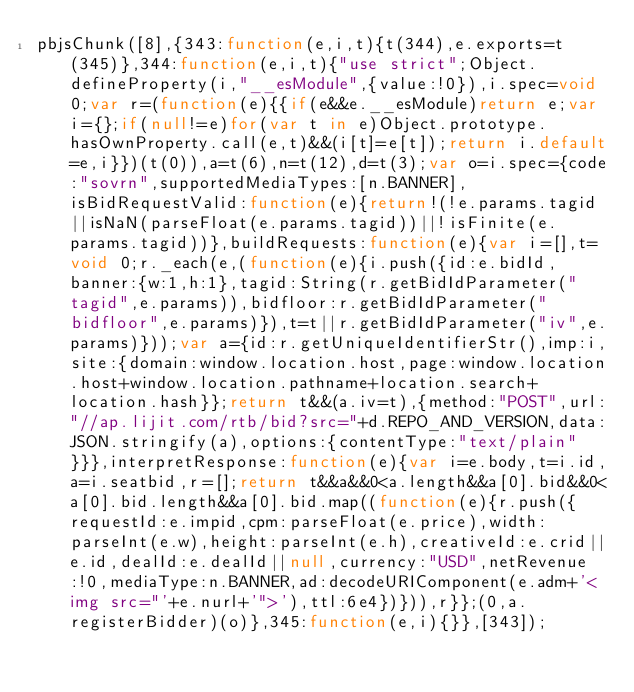<code> <loc_0><loc_0><loc_500><loc_500><_JavaScript_>pbjsChunk([8],{343:function(e,i,t){t(344),e.exports=t(345)},344:function(e,i,t){"use strict";Object.defineProperty(i,"__esModule",{value:!0}),i.spec=void 0;var r=(function(e){{if(e&&e.__esModule)return e;var i={};if(null!=e)for(var t in e)Object.prototype.hasOwnProperty.call(e,t)&&(i[t]=e[t]);return i.default=e,i}})(t(0)),a=t(6),n=t(12),d=t(3);var o=i.spec={code:"sovrn",supportedMediaTypes:[n.BANNER],isBidRequestValid:function(e){return!(!e.params.tagid||isNaN(parseFloat(e.params.tagid))||!isFinite(e.params.tagid))},buildRequests:function(e){var i=[],t=void 0;r._each(e,(function(e){i.push({id:e.bidId,banner:{w:1,h:1},tagid:String(r.getBidIdParameter("tagid",e.params)),bidfloor:r.getBidIdParameter("bidfloor",e.params)}),t=t||r.getBidIdParameter("iv",e.params)}));var a={id:r.getUniqueIdentifierStr(),imp:i,site:{domain:window.location.host,page:window.location.host+window.location.pathname+location.search+location.hash}};return t&&(a.iv=t),{method:"POST",url:"//ap.lijit.com/rtb/bid?src="+d.REPO_AND_VERSION,data:JSON.stringify(a),options:{contentType:"text/plain"}}},interpretResponse:function(e){var i=e.body,t=i.id,a=i.seatbid,r=[];return t&&a&&0<a.length&&a[0].bid&&0<a[0].bid.length&&a[0].bid.map((function(e){r.push({requestId:e.impid,cpm:parseFloat(e.price),width:parseInt(e.w),height:parseInt(e.h),creativeId:e.crid||e.id,dealId:e.dealId||null,currency:"USD",netRevenue:!0,mediaType:n.BANNER,ad:decodeURIComponent(e.adm+'<img src="'+e.nurl+'">'),ttl:6e4})})),r}};(0,a.registerBidder)(o)},345:function(e,i){}},[343]);</code> 